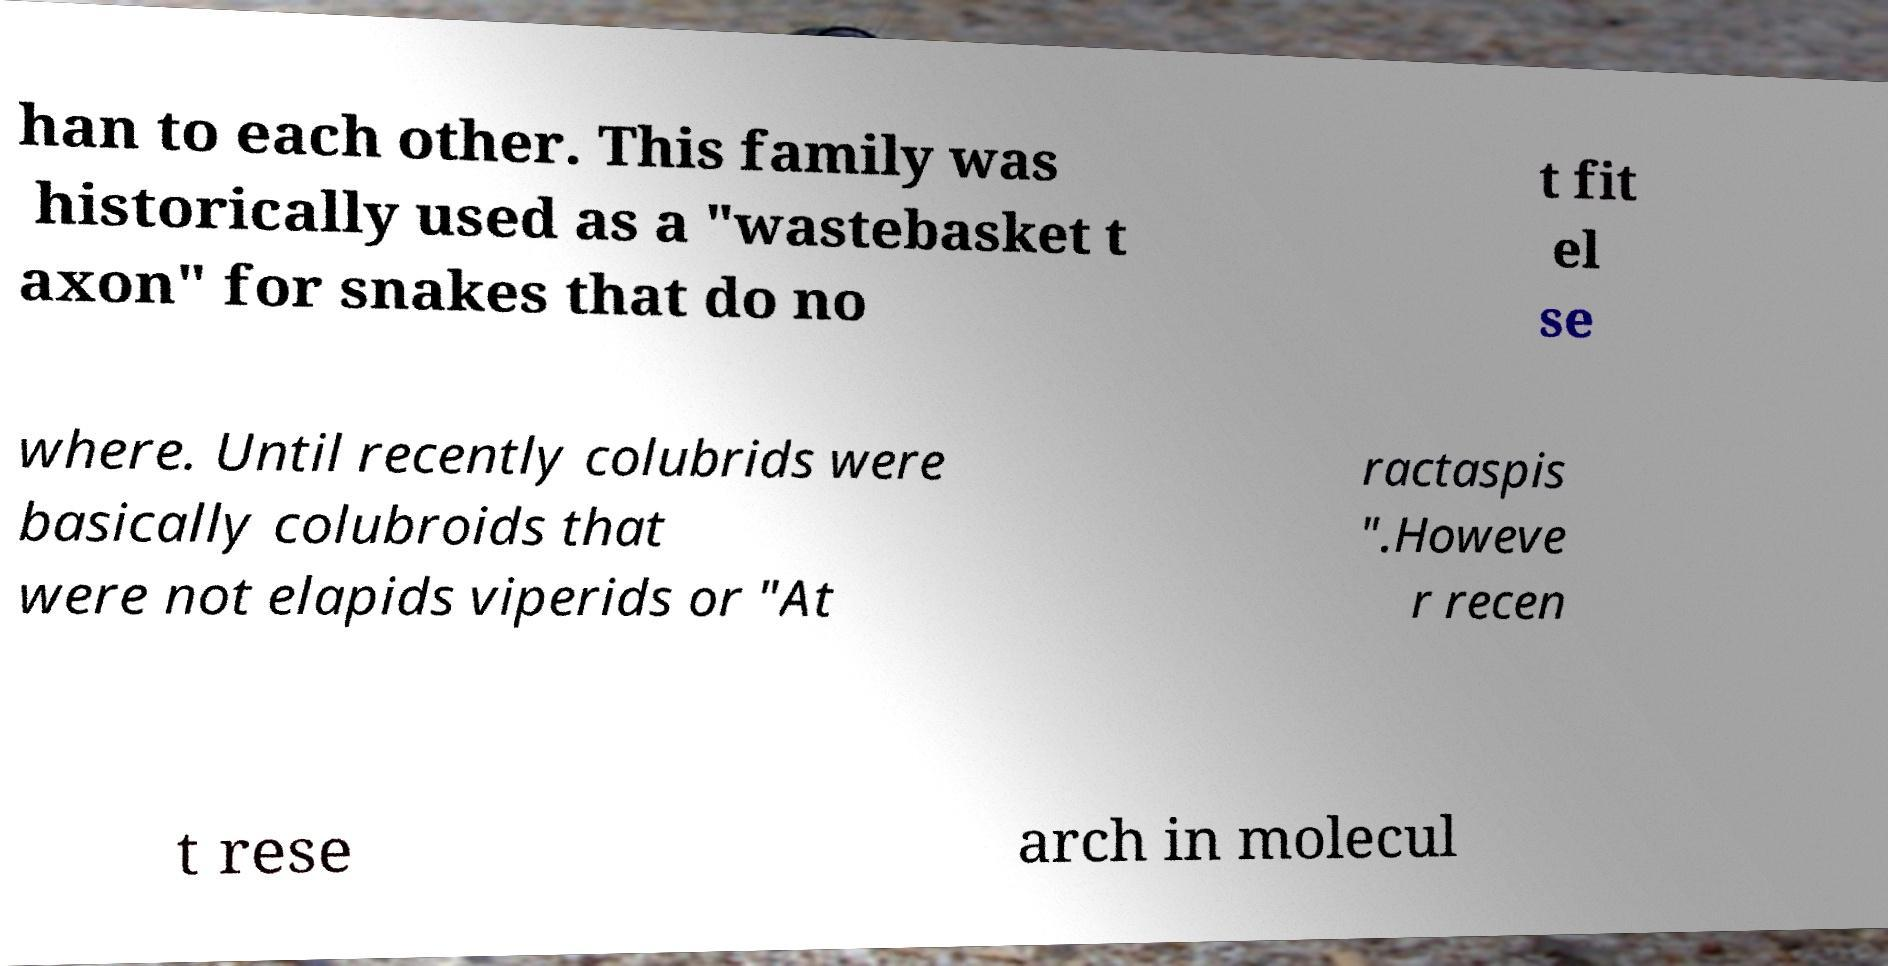Please identify and transcribe the text found in this image. han to each other. This family was historically used as a "wastebasket t axon" for snakes that do no t fit el se where. Until recently colubrids were basically colubroids that were not elapids viperids or "At ractaspis ".Howeve r recen t rese arch in molecul 